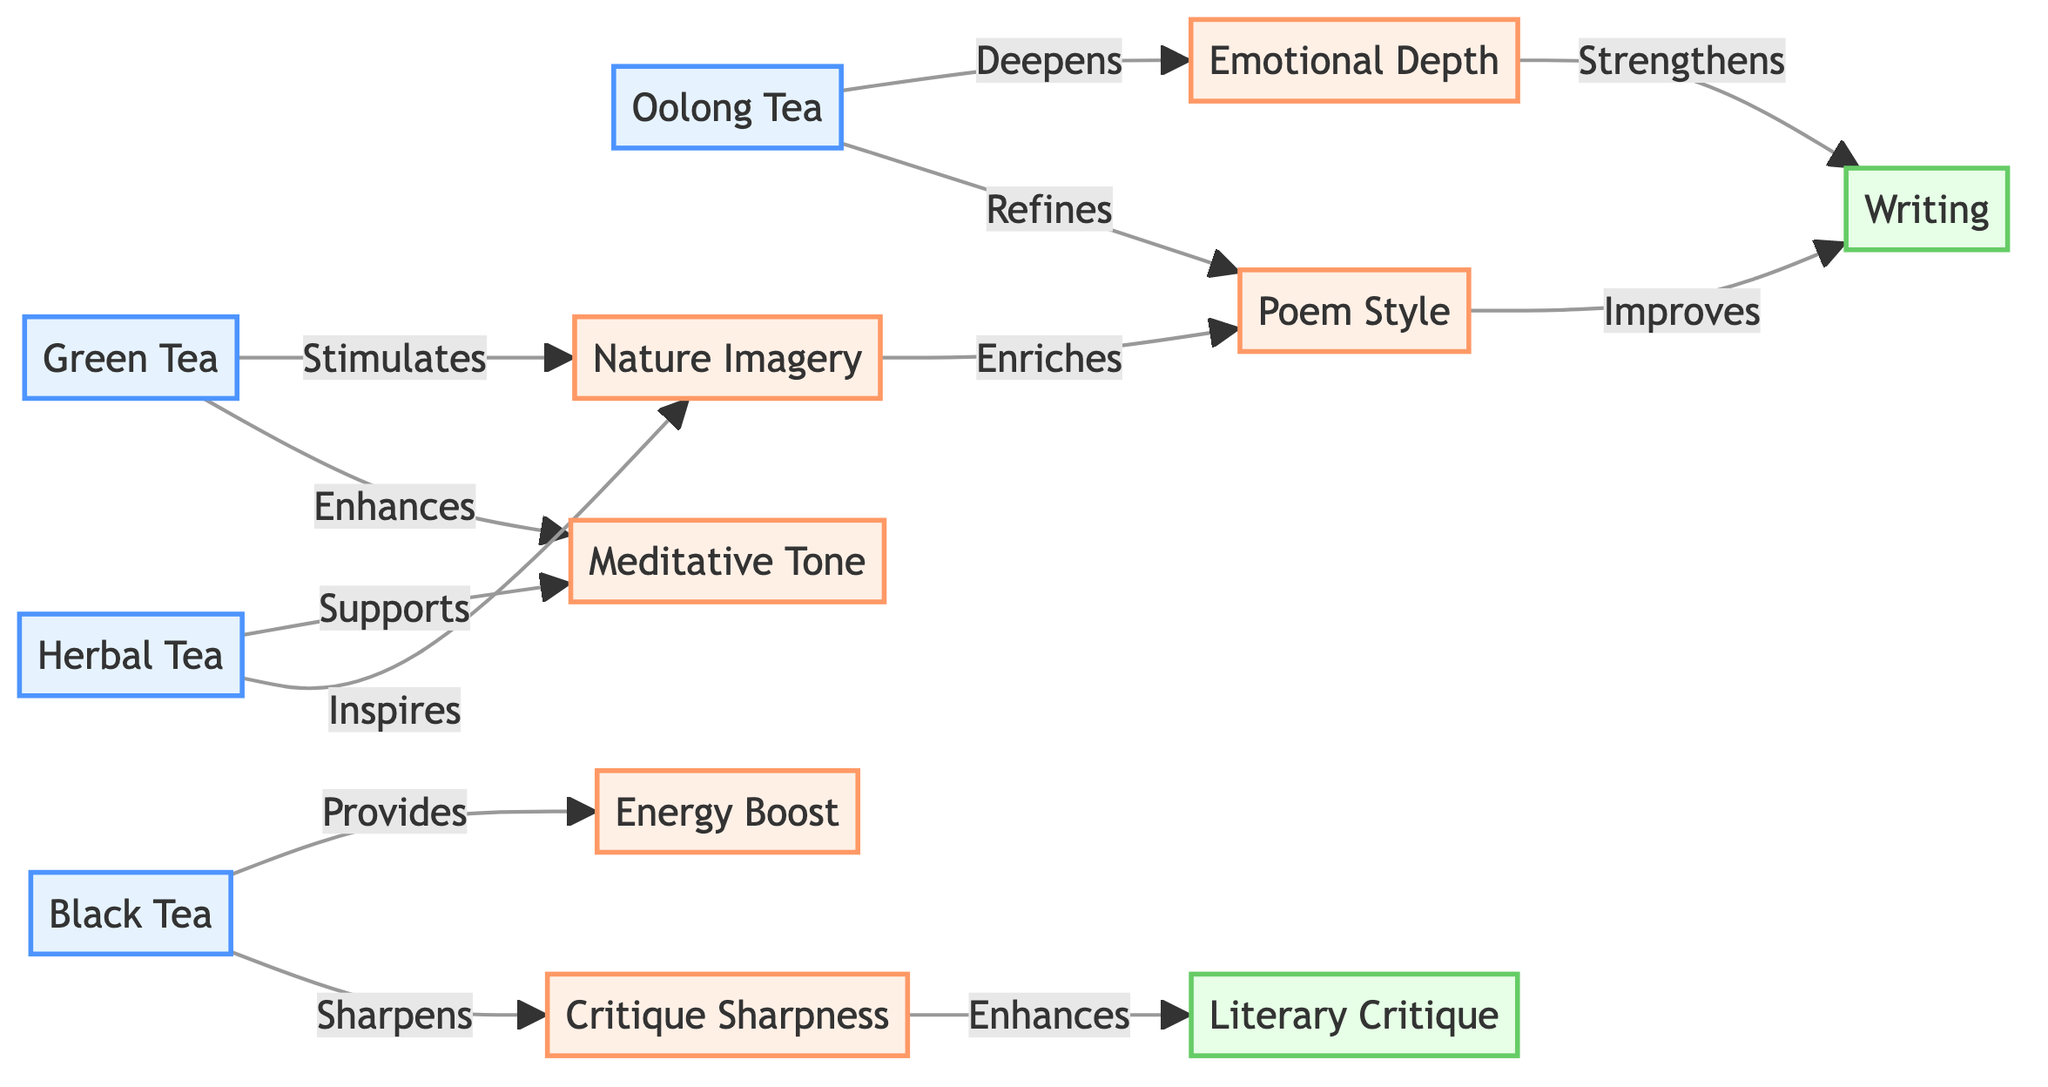What is the total number of nodes in the diagram? The diagram includes various tea varieties and related influences, which are represented as nodes. Counting each unique item listed under "nodes," there are 10 distinct nodes.
Answer: 10 Which tea variety stimulates Nature Imagery? The directed edge from Green Tea to Nature Imagery indicates that Green Tea stimulates this aspect. Therefore, the answer is Green Tea.
Answer: Green Tea How does Black Tea affect Critique Sharpness? Black Tea has a directed edge leading to Critique Sharpness labeled "Sharpens," showing that it enhances this critical quality. Thus, the effect is a sharpening influence.
Answer: Sharpens Which two tea varieties influence the Meditative Tone? The diagram shows directed edges from both Green Tea and Herbal Tea to Meditative Tone. This means both varieties support or enhance this particular tone.
Answer: Green Tea and Herbal Tea What effect does Oolong Tea have on Writing? While Oolong Tea connects to Emotional Depth and Poem Style, there isn’t a direct link from Oolong Tea to Writing. Instead, it indirectly influences Writing through Poem Style. The relationship can be traced from Oolong Tea to Poem Style, and hence indirectly to Writing.
Answer: Indirectly through Poem Style Which effect is enriched by Nature Imagery? Following the directed edge from Nature Imagery to Poem Style, it’s clear that Nature Imagery enriches Poem Style. Therefore, the answer is Poem Style.
Answer: Poem Style What is the relationship between Emotional Depth and Writing? There’s a directed edge from Emotional Depth to Writing labeled "Strengthens," indicating that Emotional Depth plays a role in enhancing or strengthening the writing quality.
Answer: Strengthens Which tea provides an Energy Boost? Black Tea has a directed edge leading to Energy Boost, specifying that this tea variety provides this particular stimulant effect.
Answer: Black Tea 